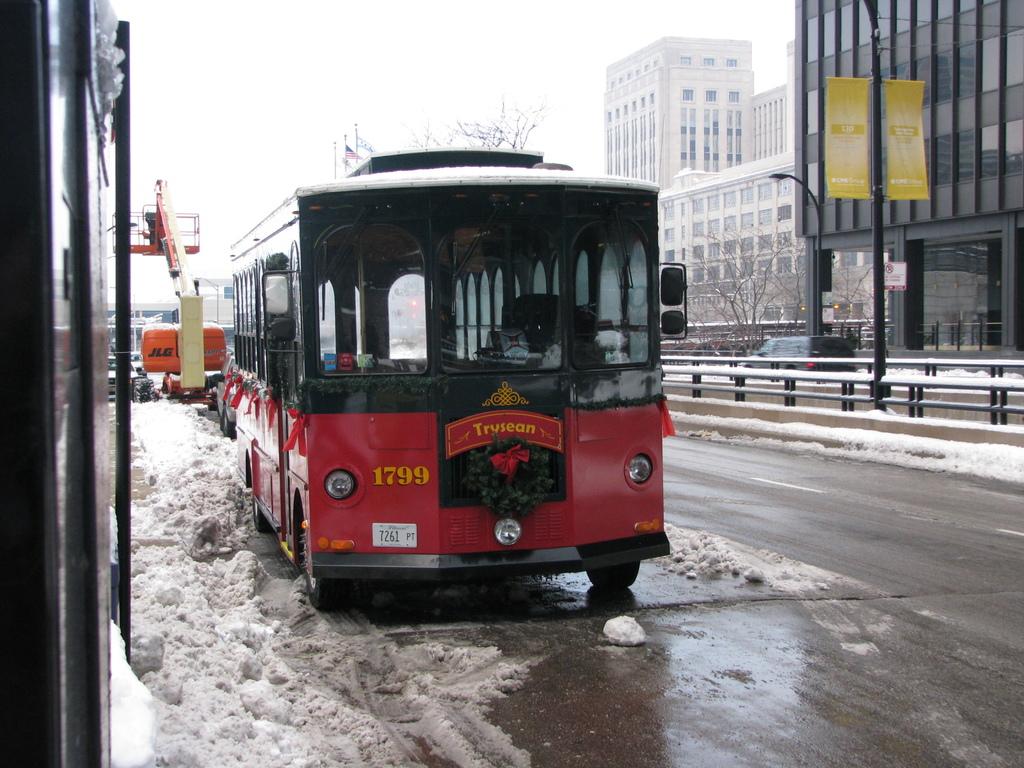What's the bus number?
Your answer should be compact. 1799. What is the tag number of the bus?
Offer a terse response. 1799. 